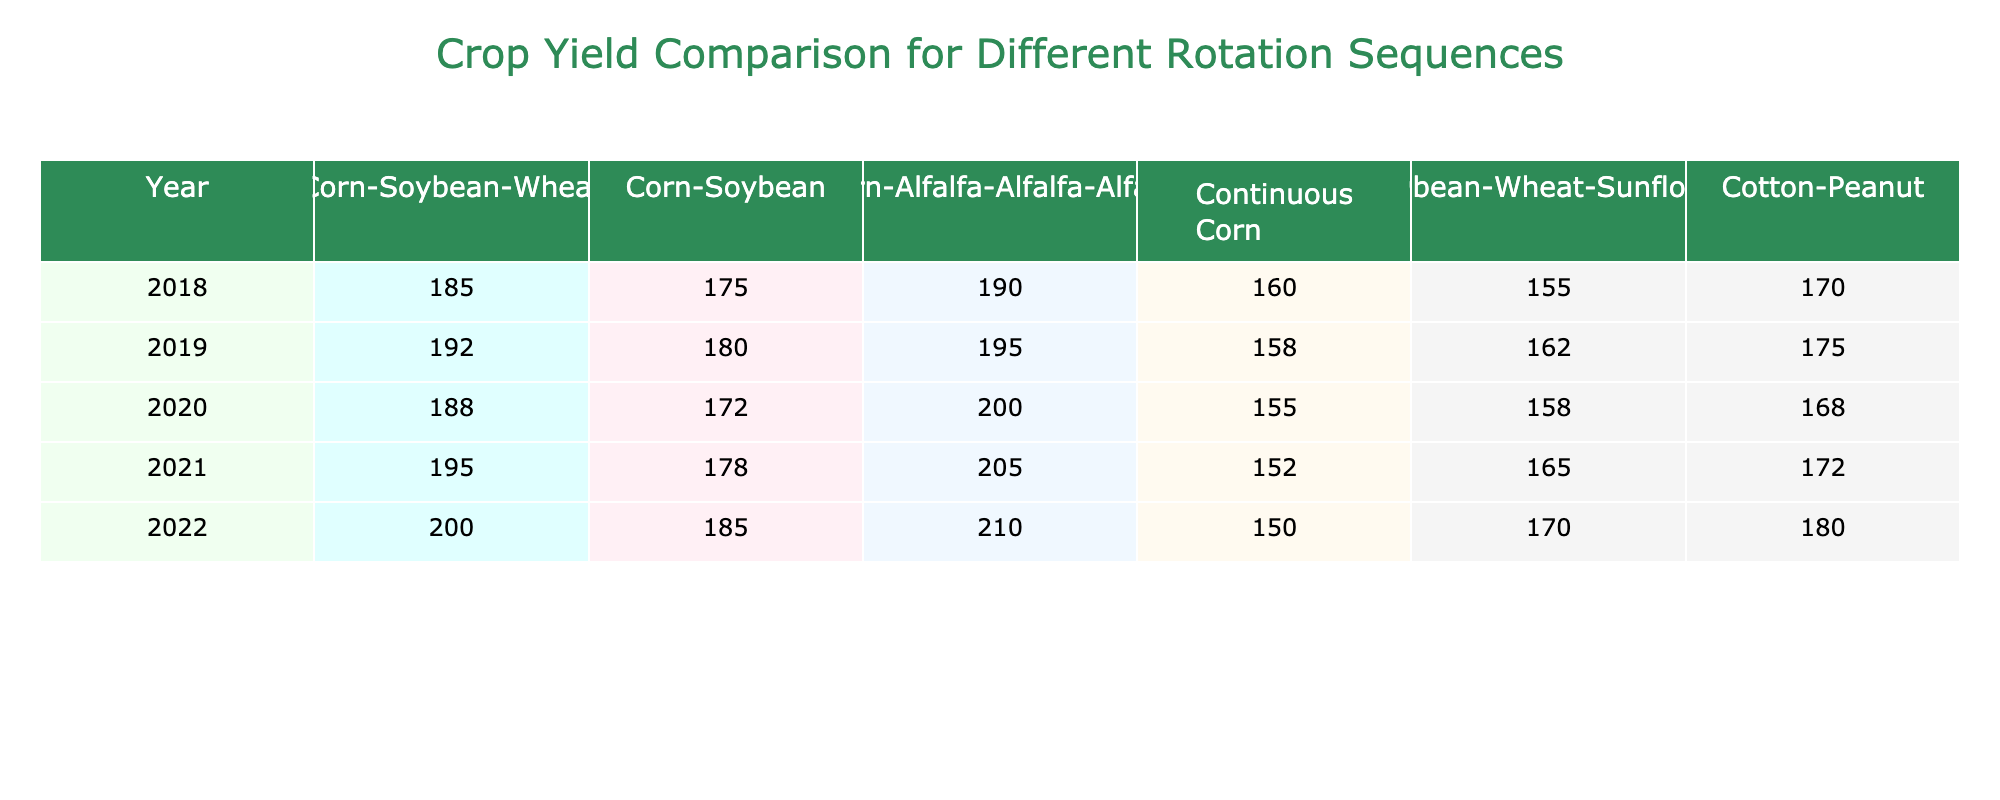What is the crop yield for Corn-Alfalfa-Alfalfa-Alfalfa in 2022? In 2022, you can look at the row for that year in the Corn-Alfalfa-Alfalfa-Alfalfa column. The value listed is 210.
Answer: 210 Which rotation sequence had the highest yield in 2019? In 2019, by comparing all the values across different rotation sequences, Corn-Alfalfa-Alfalfa-Alfalfa had the highest yield of 195.
Answer: Corn-Alfalfa-Alfalfa-Alfalfa What is the average yield for Continuous Corn over the 5 years? To find the average, add the yields for Continuous Corn from all years (160 + 158 + 155 + 152 + 150 = 775) and divide by 5, which gives 775/5 = 155.
Answer: 155 Is the yield for Soybean-Wheat-Sunflower consistently higher than Continuous Corn? By examining each corresponding year, you find that the yield for Soybean-Wheat-Sunflower is higher than Continuous Corn in all 5 years.
Answer: Yes What was the yield difference between Corn-Soybean-Wheat and Corn-Soybean in 2020? In 2020, the yield for Corn-Soybean-Wheat was 188, and for Corn-Soybean, it was 172. The difference is 188 - 172 = 16.
Answer: 16 Which rotation sequence showed the most significant yield increase from 2018 to 2022? Calculate the yield increase for each sequence from 2018 to 2022. The largest increase was seen in Corn-Alfalfa-Alfalfa-Alfalfa, which went from 190 in 2018 to 210 in 2022, an increase of 20.
Answer: Corn-Alfalfa-Alfalfa-Alfalfa What is the yield trend for Cotton-Peanut over the 5 years? By looking at the values for Cotton-Peanut (170, 175, 168, 172, 180), you can see a slight upward trend, with yields increasing in 2019 and 2021 and peaking at 180 in 2022.
Answer: Increasing Trend What was the yield for Corn-Soybean in 2021 compared to 2018? The yield for Corn-Soybean in 2021 was 178, while in 2018 it was 175. The comparison shows an increase of 3.
Answer: Increased by 3 Did any rotation sequence have a yield below 160 in any year? A review of the data shows that Continuous Corn had a yield below 160 in every year, with the lowest being 150 in 2022.
Answer: Yes What is the total yield for Corn-Soybean-Wheat from 2018 to 2022? To find the total yield, add the yields for Corn-Soybean-Wheat across the years: (185 + 192 + 188 + 195 + 200 = 960).
Answer: 960 